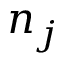<formula> <loc_0><loc_0><loc_500><loc_500>n _ { j }</formula> 